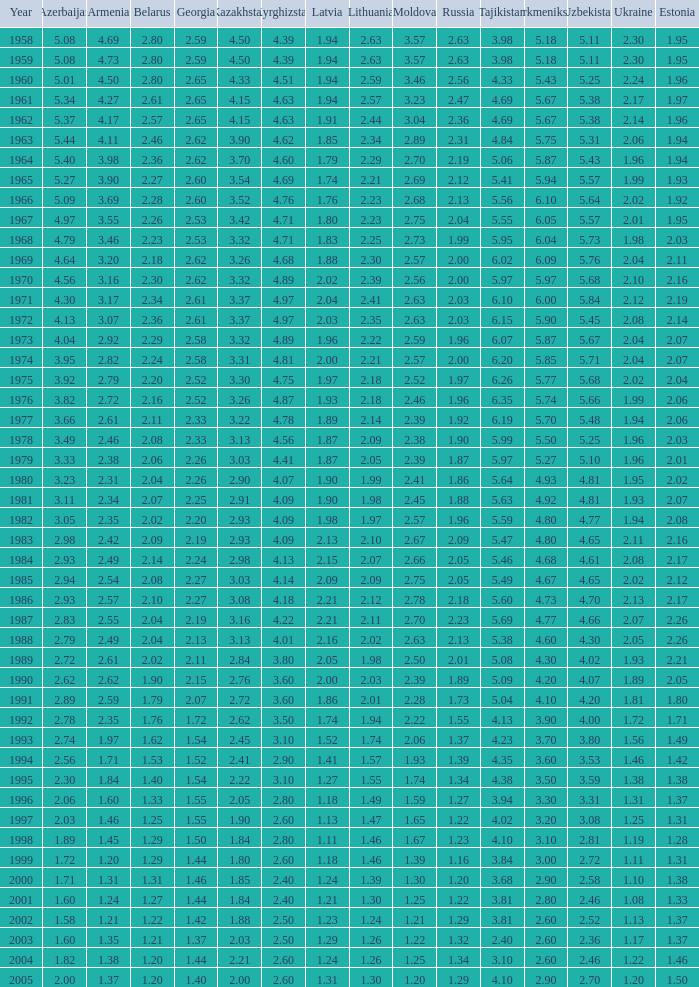46 None. 